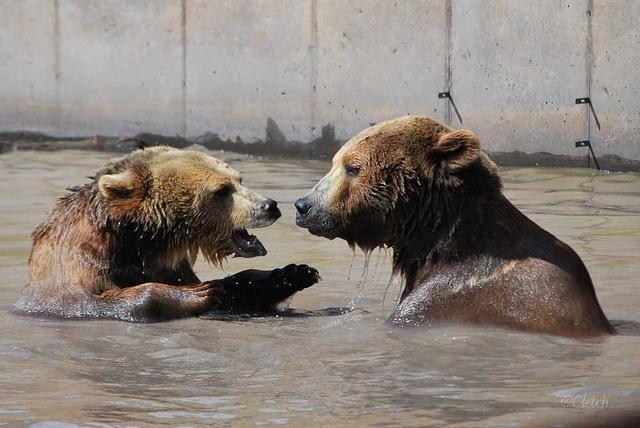How many bears have exposed paws?
Give a very brief answer. 1. How many bears are in the picture?
Give a very brief answer. 2. 